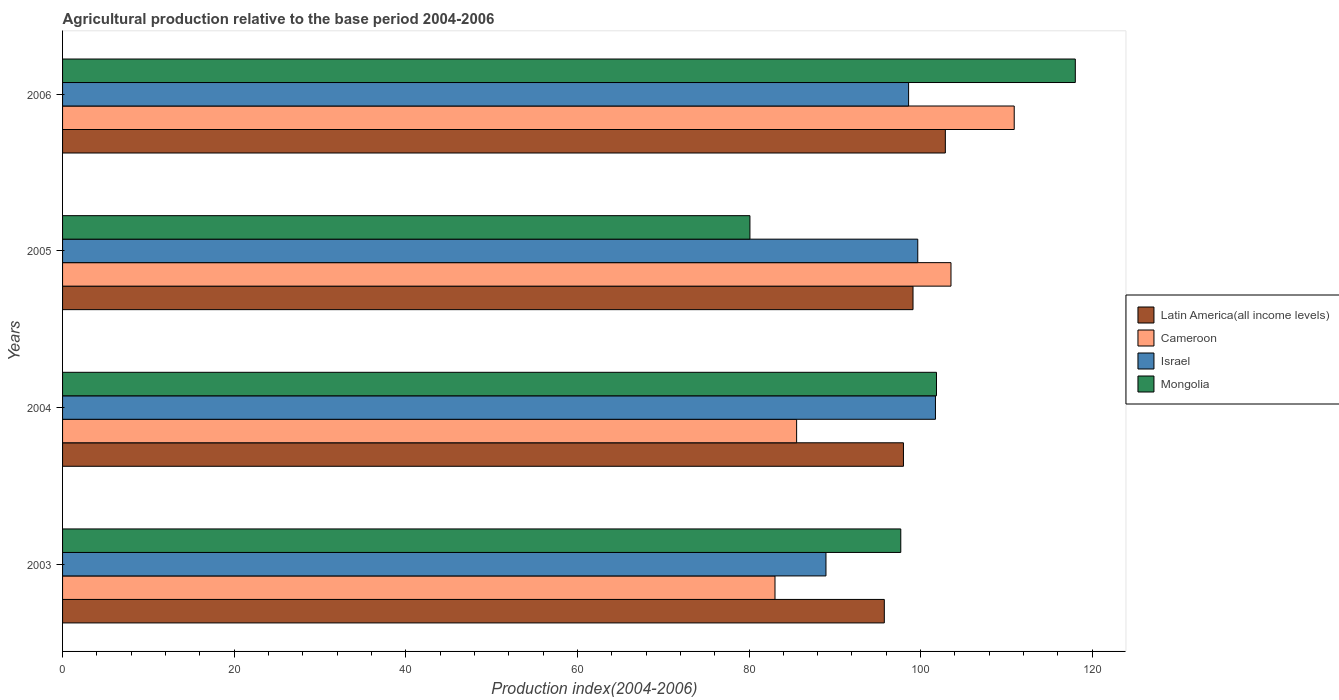How many different coloured bars are there?
Keep it short and to the point. 4. How many bars are there on the 4th tick from the top?
Ensure brevity in your answer.  4. How many bars are there on the 3rd tick from the bottom?
Offer a terse response. 4. What is the agricultural production index in Israel in 2004?
Provide a succinct answer. 101.73. Across all years, what is the maximum agricultural production index in Latin America(all income levels)?
Offer a very short reply. 102.88. Across all years, what is the minimum agricultural production index in Mongolia?
Your answer should be very brief. 80.11. In which year was the agricultural production index in Latin America(all income levels) minimum?
Provide a short and direct response. 2003. What is the total agricultural production index in Mongolia in the graph?
Offer a very short reply. 397.68. What is the difference between the agricultural production index in Israel in 2005 and that in 2006?
Your response must be concise. 1.07. What is the difference between the agricultural production index in Latin America(all income levels) in 2006 and the agricultural production index in Israel in 2005?
Provide a short and direct response. 3.21. What is the average agricultural production index in Cameroon per year?
Offer a terse response. 95.76. In the year 2005, what is the difference between the agricultural production index in Latin America(all income levels) and agricultural production index in Mongolia?
Your response must be concise. 19.01. In how many years, is the agricultural production index in Mongolia greater than 24 ?
Offer a very short reply. 4. What is the ratio of the agricultural production index in Israel in 2003 to that in 2005?
Your response must be concise. 0.89. What is the difference between the highest and the second highest agricultural production index in Latin America(all income levels)?
Your answer should be compact. 3.77. What is the difference between the highest and the lowest agricultural production index in Israel?
Offer a terse response. 12.76. Is it the case that in every year, the sum of the agricultural production index in Israel and agricultural production index in Latin America(all income levels) is greater than the sum of agricultural production index in Mongolia and agricultural production index in Cameroon?
Offer a very short reply. Yes. What does the 1st bar from the top in 2004 represents?
Your answer should be compact. Mongolia. What does the 3rd bar from the bottom in 2005 represents?
Offer a very short reply. Israel. How many bars are there?
Provide a short and direct response. 16. Are all the bars in the graph horizontal?
Provide a succinct answer. Yes. What is the difference between two consecutive major ticks on the X-axis?
Your answer should be compact. 20. Does the graph contain any zero values?
Provide a short and direct response. No. Does the graph contain grids?
Offer a very short reply. No. How are the legend labels stacked?
Make the answer very short. Vertical. What is the title of the graph?
Provide a short and direct response. Agricultural production relative to the base period 2004-2006. What is the label or title of the X-axis?
Offer a very short reply. Production index(2004-2006). What is the label or title of the Y-axis?
Ensure brevity in your answer.  Years. What is the Production index(2004-2006) in Latin America(all income levels) in 2003?
Provide a succinct answer. 95.77. What is the Production index(2004-2006) of Cameroon in 2003?
Offer a very short reply. 83.03. What is the Production index(2004-2006) of Israel in 2003?
Offer a very short reply. 88.97. What is the Production index(2004-2006) of Mongolia in 2003?
Keep it short and to the point. 97.69. What is the Production index(2004-2006) of Latin America(all income levels) in 2004?
Give a very brief answer. 98. What is the Production index(2004-2006) of Cameroon in 2004?
Ensure brevity in your answer.  85.55. What is the Production index(2004-2006) in Israel in 2004?
Ensure brevity in your answer.  101.73. What is the Production index(2004-2006) of Mongolia in 2004?
Ensure brevity in your answer.  101.85. What is the Production index(2004-2006) in Latin America(all income levels) in 2005?
Keep it short and to the point. 99.12. What is the Production index(2004-2006) in Cameroon in 2005?
Your response must be concise. 103.54. What is the Production index(2004-2006) in Israel in 2005?
Give a very brief answer. 99.67. What is the Production index(2004-2006) in Mongolia in 2005?
Offer a terse response. 80.11. What is the Production index(2004-2006) of Latin America(all income levels) in 2006?
Give a very brief answer. 102.88. What is the Production index(2004-2006) in Cameroon in 2006?
Your answer should be compact. 110.91. What is the Production index(2004-2006) in Israel in 2006?
Make the answer very short. 98.6. What is the Production index(2004-2006) of Mongolia in 2006?
Your answer should be compact. 118.03. Across all years, what is the maximum Production index(2004-2006) in Latin America(all income levels)?
Offer a very short reply. 102.88. Across all years, what is the maximum Production index(2004-2006) of Cameroon?
Make the answer very short. 110.91. Across all years, what is the maximum Production index(2004-2006) in Israel?
Keep it short and to the point. 101.73. Across all years, what is the maximum Production index(2004-2006) in Mongolia?
Your answer should be compact. 118.03. Across all years, what is the minimum Production index(2004-2006) in Latin America(all income levels)?
Offer a terse response. 95.77. Across all years, what is the minimum Production index(2004-2006) in Cameroon?
Your response must be concise. 83.03. Across all years, what is the minimum Production index(2004-2006) in Israel?
Provide a short and direct response. 88.97. Across all years, what is the minimum Production index(2004-2006) of Mongolia?
Offer a terse response. 80.11. What is the total Production index(2004-2006) of Latin America(all income levels) in the graph?
Offer a terse response. 395.77. What is the total Production index(2004-2006) in Cameroon in the graph?
Your response must be concise. 383.03. What is the total Production index(2004-2006) in Israel in the graph?
Provide a short and direct response. 388.97. What is the total Production index(2004-2006) of Mongolia in the graph?
Offer a very short reply. 397.68. What is the difference between the Production index(2004-2006) in Latin America(all income levels) in 2003 and that in 2004?
Make the answer very short. -2.23. What is the difference between the Production index(2004-2006) in Cameroon in 2003 and that in 2004?
Provide a succinct answer. -2.52. What is the difference between the Production index(2004-2006) of Israel in 2003 and that in 2004?
Ensure brevity in your answer.  -12.76. What is the difference between the Production index(2004-2006) in Mongolia in 2003 and that in 2004?
Give a very brief answer. -4.16. What is the difference between the Production index(2004-2006) of Latin America(all income levels) in 2003 and that in 2005?
Keep it short and to the point. -3.35. What is the difference between the Production index(2004-2006) of Cameroon in 2003 and that in 2005?
Your response must be concise. -20.51. What is the difference between the Production index(2004-2006) of Israel in 2003 and that in 2005?
Offer a terse response. -10.7. What is the difference between the Production index(2004-2006) in Mongolia in 2003 and that in 2005?
Your response must be concise. 17.58. What is the difference between the Production index(2004-2006) of Latin America(all income levels) in 2003 and that in 2006?
Give a very brief answer. -7.11. What is the difference between the Production index(2004-2006) in Cameroon in 2003 and that in 2006?
Offer a terse response. -27.88. What is the difference between the Production index(2004-2006) of Israel in 2003 and that in 2006?
Make the answer very short. -9.63. What is the difference between the Production index(2004-2006) of Mongolia in 2003 and that in 2006?
Your answer should be compact. -20.34. What is the difference between the Production index(2004-2006) in Latin America(all income levels) in 2004 and that in 2005?
Give a very brief answer. -1.12. What is the difference between the Production index(2004-2006) of Cameroon in 2004 and that in 2005?
Provide a short and direct response. -17.99. What is the difference between the Production index(2004-2006) in Israel in 2004 and that in 2005?
Provide a short and direct response. 2.06. What is the difference between the Production index(2004-2006) in Mongolia in 2004 and that in 2005?
Give a very brief answer. 21.74. What is the difference between the Production index(2004-2006) in Latin America(all income levels) in 2004 and that in 2006?
Your answer should be compact. -4.88. What is the difference between the Production index(2004-2006) of Cameroon in 2004 and that in 2006?
Ensure brevity in your answer.  -25.36. What is the difference between the Production index(2004-2006) in Israel in 2004 and that in 2006?
Your response must be concise. 3.13. What is the difference between the Production index(2004-2006) in Mongolia in 2004 and that in 2006?
Make the answer very short. -16.18. What is the difference between the Production index(2004-2006) in Latin America(all income levels) in 2005 and that in 2006?
Offer a terse response. -3.77. What is the difference between the Production index(2004-2006) in Cameroon in 2005 and that in 2006?
Offer a terse response. -7.37. What is the difference between the Production index(2004-2006) of Israel in 2005 and that in 2006?
Offer a terse response. 1.07. What is the difference between the Production index(2004-2006) of Mongolia in 2005 and that in 2006?
Keep it short and to the point. -37.92. What is the difference between the Production index(2004-2006) of Latin America(all income levels) in 2003 and the Production index(2004-2006) of Cameroon in 2004?
Offer a terse response. 10.22. What is the difference between the Production index(2004-2006) of Latin America(all income levels) in 2003 and the Production index(2004-2006) of Israel in 2004?
Your answer should be very brief. -5.96. What is the difference between the Production index(2004-2006) of Latin America(all income levels) in 2003 and the Production index(2004-2006) of Mongolia in 2004?
Your answer should be compact. -6.08. What is the difference between the Production index(2004-2006) of Cameroon in 2003 and the Production index(2004-2006) of Israel in 2004?
Offer a very short reply. -18.7. What is the difference between the Production index(2004-2006) in Cameroon in 2003 and the Production index(2004-2006) in Mongolia in 2004?
Provide a short and direct response. -18.82. What is the difference between the Production index(2004-2006) in Israel in 2003 and the Production index(2004-2006) in Mongolia in 2004?
Offer a terse response. -12.88. What is the difference between the Production index(2004-2006) of Latin America(all income levels) in 2003 and the Production index(2004-2006) of Cameroon in 2005?
Offer a terse response. -7.77. What is the difference between the Production index(2004-2006) in Latin America(all income levels) in 2003 and the Production index(2004-2006) in Israel in 2005?
Offer a very short reply. -3.9. What is the difference between the Production index(2004-2006) in Latin America(all income levels) in 2003 and the Production index(2004-2006) in Mongolia in 2005?
Your answer should be compact. 15.66. What is the difference between the Production index(2004-2006) in Cameroon in 2003 and the Production index(2004-2006) in Israel in 2005?
Make the answer very short. -16.64. What is the difference between the Production index(2004-2006) in Cameroon in 2003 and the Production index(2004-2006) in Mongolia in 2005?
Provide a succinct answer. 2.92. What is the difference between the Production index(2004-2006) in Israel in 2003 and the Production index(2004-2006) in Mongolia in 2005?
Your response must be concise. 8.86. What is the difference between the Production index(2004-2006) in Latin America(all income levels) in 2003 and the Production index(2004-2006) in Cameroon in 2006?
Offer a terse response. -15.14. What is the difference between the Production index(2004-2006) in Latin America(all income levels) in 2003 and the Production index(2004-2006) in Israel in 2006?
Provide a succinct answer. -2.83. What is the difference between the Production index(2004-2006) in Latin America(all income levels) in 2003 and the Production index(2004-2006) in Mongolia in 2006?
Make the answer very short. -22.26. What is the difference between the Production index(2004-2006) in Cameroon in 2003 and the Production index(2004-2006) in Israel in 2006?
Provide a succinct answer. -15.57. What is the difference between the Production index(2004-2006) of Cameroon in 2003 and the Production index(2004-2006) of Mongolia in 2006?
Your answer should be compact. -35. What is the difference between the Production index(2004-2006) of Israel in 2003 and the Production index(2004-2006) of Mongolia in 2006?
Offer a very short reply. -29.06. What is the difference between the Production index(2004-2006) of Latin America(all income levels) in 2004 and the Production index(2004-2006) of Cameroon in 2005?
Your answer should be compact. -5.54. What is the difference between the Production index(2004-2006) of Latin America(all income levels) in 2004 and the Production index(2004-2006) of Israel in 2005?
Your answer should be very brief. -1.67. What is the difference between the Production index(2004-2006) in Latin America(all income levels) in 2004 and the Production index(2004-2006) in Mongolia in 2005?
Give a very brief answer. 17.89. What is the difference between the Production index(2004-2006) of Cameroon in 2004 and the Production index(2004-2006) of Israel in 2005?
Offer a terse response. -14.12. What is the difference between the Production index(2004-2006) in Cameroon in 2004 and the Production index(2004-2006) in Mongolia in 2005?
Offer a very short reply. 5.44. What is the difference between the Production index(2004-2006) of Israel in 2004 and the Production index(2004-2006) of Mongolia in 2005?
Provide a short and direct response. 21.62. What is the difference between the Production index(2004-2006) of Latin America(all income levels) in 2004 and the Production index(2004-2006) of Cameroon in 2006?
Give a very brief answer. -12.91. What is the difference between the Production index(2004-2006) in Latin America(all income levels) in 2004 and the Production index(2004-2006) in Israel in 2006?
Your answer should be very brief. -0.6. What is the difference between the Production index(2004-2006) of Latin America(all income levels) in 2004 and the Production index(2004-2006) of Mongolia in 2006?
Provide a succinct answer. -20.03. What is the difference between the Production index(2004-2006) in Cameroon in 2004 and the Production index(2004-2006) in Israel in 2006?
Keep it short and to the point. -13.05. What is the difference between the Production index(2004-2006) of Cameroon in 2004 and the Production index(2004-2006) of Mongolia in 2006?
Your answer should be compact. -32.48. What is the difference between the Production index(2004-2006) of Israel in 2004 and the Production index(2004-2006) of Mongolia in 2006?
Your response must be concise. -16.3. What is the difference between the Production index(2004-2006) in Latin America(all income levels) in 2005 and the Production index(2004-2006) in Cameroon in 2006?
Your response must be concise. -11.79. What is the difference between the Production index(2004-2006) of Latin America(all income levels) in 2005 and the Production index(2004-2006) of Israel in 2006?
Provide a short and direct response. 0.52. What is the difference between the Production index(2004-2006) of Latin America(all income levels) in 2005 and the Production index(2004-2006) of Mongolia in 2006?
Offer a very short reply. -18.91. What is the difference between the Production index(2004-2006) of Cameroon in 2005 and the Production index(2004-2006) of Israel in 2006?
Offer a terse response. 4.94. What is the difference between the Production index(2004-2006) of Cameroon in 2005 and the Production index(2004-2006) of Mongolia in 2006?
Your response must be concise. -14.49. What is the difference between the Production index(2004-2006) of Israel in 2005 and the Production index(2004-2006) of Mongolia in 2006?
Give a very brief answer. -18.36. What is the average Production index(2004-2006) of Latin America(all income levels) per year?
Keep it short and to the point. 98.94. What is the average Production index(2004-2006) in Cameroon per year?
Offer a terse response. 95.76. What is the average Production index(2004-2006) of Israel per year?
Offer a terse response. 97.24. What is the average Production index(2004-2006) in Mongolia per year?
Your response must be concise. 99.42. In the year 2003, what is the difference between the Production index(2004-2006) of Latin America(all income levels) and Production index(2004-2006) of Cameroon?
Give a very brief answer. 12.74. In the year 2003, what is the difference between the Production index(2004-2006) in Latin America(all income levels) and Production index(2004-2006) in Israel?
Provide a succinct answer. 6.8. In the year 2003, what is the difference between the Production index(2004-2006) in Latin America(all income levels) and Production index(2004-2006) in Mongolia?
Make the answer very short. -1.92. In the year 2003, what is the difference between the Production index(2004-2006) of Cameroon and Production index(2004-2006) of Israel?
Your answer should be very brief. -5.94. In the year 2003, what is the difference between the Production index(2004-2006) of Cameroon and Production index(2004-2006) of Mongolia?
Make the answer very short. -14.66. In the year 2003, what is the difference between the Production index(2004-2006) of Israel and Production index(2004-2006) of Mongolia?
Make the answer very short. -8.72. In the year 2004, what is the difference between the Production index(2004-2006) of Latin America(all income levels) and Production index(2004-2006) of Cameroon?
Offer a very short reply. 12.45. In the year 2004, what is the difference between the Production index(2004-2006) in Latin America(all income levels) and Production index(2004-2006) in Israel?
Keep it short and to the point. -3.73. In the year 2004, what is the difference between the Production index(2004-2006) of Latin America(all income levels) and Production index(2004-2006) of Mongolia?
Offer a terse response. -3.85. In the year 2004, what is the difference between the Production index(2004-2006) in Cameroon and Production index(2004-2006) in Israel?
Ensure brevity in your answer.  -16.18. In the year 2004, what is the difference between the Production index(2004-2006) of Cameroon and Production index(2004-2006) of Mongolia?
Your answer should be compact. -16.3. In the year 2004, what is the difference between the Production index(2004-2006) in Israel and Production index(2004-2006) in Mongolia?
Offer a terse response. -0.12. In the year 2005, what is the difference between the Production index(2004-2006) of Latin America(all income levels) and Production index(2004-2006) of Cameroon?
Provide a short and direct response. -4.42. In the year 2005, what is the difference between the Production index(2004-2006) in Latin America(all income levels) and Production index(2004-2006) in Israel?
Make the answer very short. -0.55. In the year 2005, what is the difference between the Production index(2004-2006) of Latin America(all income levels) and Production index(2004-2006) of Mongolia?
Keep it short and to the point. 19.01. In the year 2005, what is the difference between the Production index(2004-2006) of Cameroon and Production index(2004-2006) of Israel?
Give a very brief answer. 3.87. In the year 2005, what is the difference between the Production index(2004-2006) of Cameroon and Production index(2004-2006) of Mongolia?
Make the answer very short. 23.43. In the year 2005, what is the difference between the Production index(2004-2006) of Israel and Production index(2004-2006) of Mongolia?
Your answer should be compact. 19.56. In the year 2006, what is the difference between the Production index(2004-2006) of Latin America(all income levels) and Production index(2004-2006) of Cameroon?
Give a very brief answer. -8.03. In the year 2006, what is the difference between the Production index(2004-2006) in Latin America(all income levels) and Production index(2004-2006) in Israel?
Ensure brevity in your answer.  4.28. In the year 2006, what is the difference between the Production index(2004-2006) of Latin America(all income levels) and Production index(2004-2006) of Mongolia?
Provide a succinct answer. -15.15. In the year 2006, what is the difference between the Production index(2004-2006) of Cameroon and Production index(2004-2006) of Israel?
Give a very brief answer. 12.31. In the year 2006, what is the difference between the Production index(2004-2006) of Cameroon and Production index(2004-2006) of Mongolia?
Ensure brevity in your answer.  -7.12. In the year 2006, what is the difference between the Production index(2004-2006) of Israel and Production index(2004-2006) of Mongolia?
Make the answer very short. -19.43. What is the ratio of the Production index(2004-2006) of Latin America(all income levels) in 2003 to that in 2004?
Ensure brevity in your answer.  0.98. What is the ratio of the Production index(2004-2006) in Cameroon in 2003 to that in 2004?
Ensure brevity in your answer.  0.97. What is the ratio of the Production index(2004-2006) in Israel in 2003 to that in 2004?
Give a very brief answer. 0.87. What is the ratio of the Production index(2004-2006) of Mongolia in 2003 to that in 2004?
Your answer should be compact. 0.96. What is the ratio of the Production index(2004-2006) of Latin America(all income levels) in 2003 to that in 2005?
Ensure brevity in your answer.  0.97. What is the ratio of the Production index(2004-2006) of Cameroon in 2003 to that in 2005?
Ensure brevity in your answer.  0.8. What is the ratio of the Production index(2004-2006) of Israel in 2003 to that in 2005?
Give a very brief answer. 0.89. What is the ratio of the Production index(2004-2006) in Mongolia in 2003 to that in 2005?
Give a very brief answer. 1.22. What is the ratio of the Production index(2004-2006) in Latin America(all income levels) in 2003 to that in 2006?
Your answer should be compact. 0.93. What is the ratio of the Production index(2004-2006) in Cameroon in 2003 to that in 2006?
Your answer should be very brief. 0.75. What is the ratio of the Production index(2004-2006) in Israel in 2003 to that in 2006?
Your answer should be compact. 0.9. What is the ratio of the Production index(2004-2006) in Mongolia in 2003 to that in 2006?
Give a very brief answer. 0.83. What is the ratio of the Production index(2004-2006) of Latin America(all income levels) in 2004 to that in 2005?
Your answer should be compact. 0.99. What is the ratio of the Production index(2004-2006) in Cameroon in 2004 to that in 2005?
Offer a terse response. 0.83. What is the ratio of the Production index(2004-2006) in Israel in 2004 to that in 2005?
Offer a very short reply. 1.02. What is the ratio of the Production index(2004-2006) of Mongolia in 2004 to that in 2005?
Your answer should be compact. 1.27. What is the ratio of the Production index(2004-2006) in Latin America(all income levels) in 2004 to that in 2006?
Offer a very short reply. 0.95. What is the ratio of the Production index(2004-2006) in Cameroon in 2004 to that in 2006?
Offer a terse response. 0.77. What is the ratio of the Production index(2004-2006) of Israel in 2004 to that in 2006?
Make the answer very short. 1.03. What is the ratio of the Production index(2004-2006) of Mongolia in 2004 to that in 2006?
Your answer should be compact. 0.86. What is the ratio of the Production index(2004-2006) in Latin America(all income levels) in 2005 to that in 2006?
Make the answer very short. 0.96. What is the ratio of the Production index(2004-2006) in Cameroon in 2005 to that in 2006?
Give a very brief answer. 0.93. What is the ratio of the Production index(2004-2006) of Israel in 2005 to that in 2006?
Your response must be concise. 1.01. What is the ratio of the Production index(2004-2006) in Mongolia in 2005 to that in 2006?
Your answer should be compact. 0.68. What is the difference between the highest and the second highest Production index(2004-2006) in Latin America(all income levels)?
Your answer should be very brief. 3.77. What is the difference between the highest and the second highest Production index(2004-2006) of Cameroon?
Your answer should be very brief. 7.37. What is the difference between the highest and the second highest Production index(2004-2006) of Israel?
Give a very brief answer. 2.06. What is the difference between the highest and the second highest Production index(2004-2006) of Mongolia?
Keep it short and to the point. 16.18. What is the difference between the highest and the lowest Production index(2004-2006) of Latin America(all income levels)?
Make the answer very short. 7.11. What is the difference between the highest and the lowest Production index(2004-2006) of Cameroon?
Provide a succinct answer. 27.88. What is the difference between the highest and the lowest Production index(2004-2006) in Israel?
Provide a succinct answer. 12.76. What is the difference between the highest and the lowest Production index(2004-2006) of Mongolia?
Offer a very short reply. 37.92. 